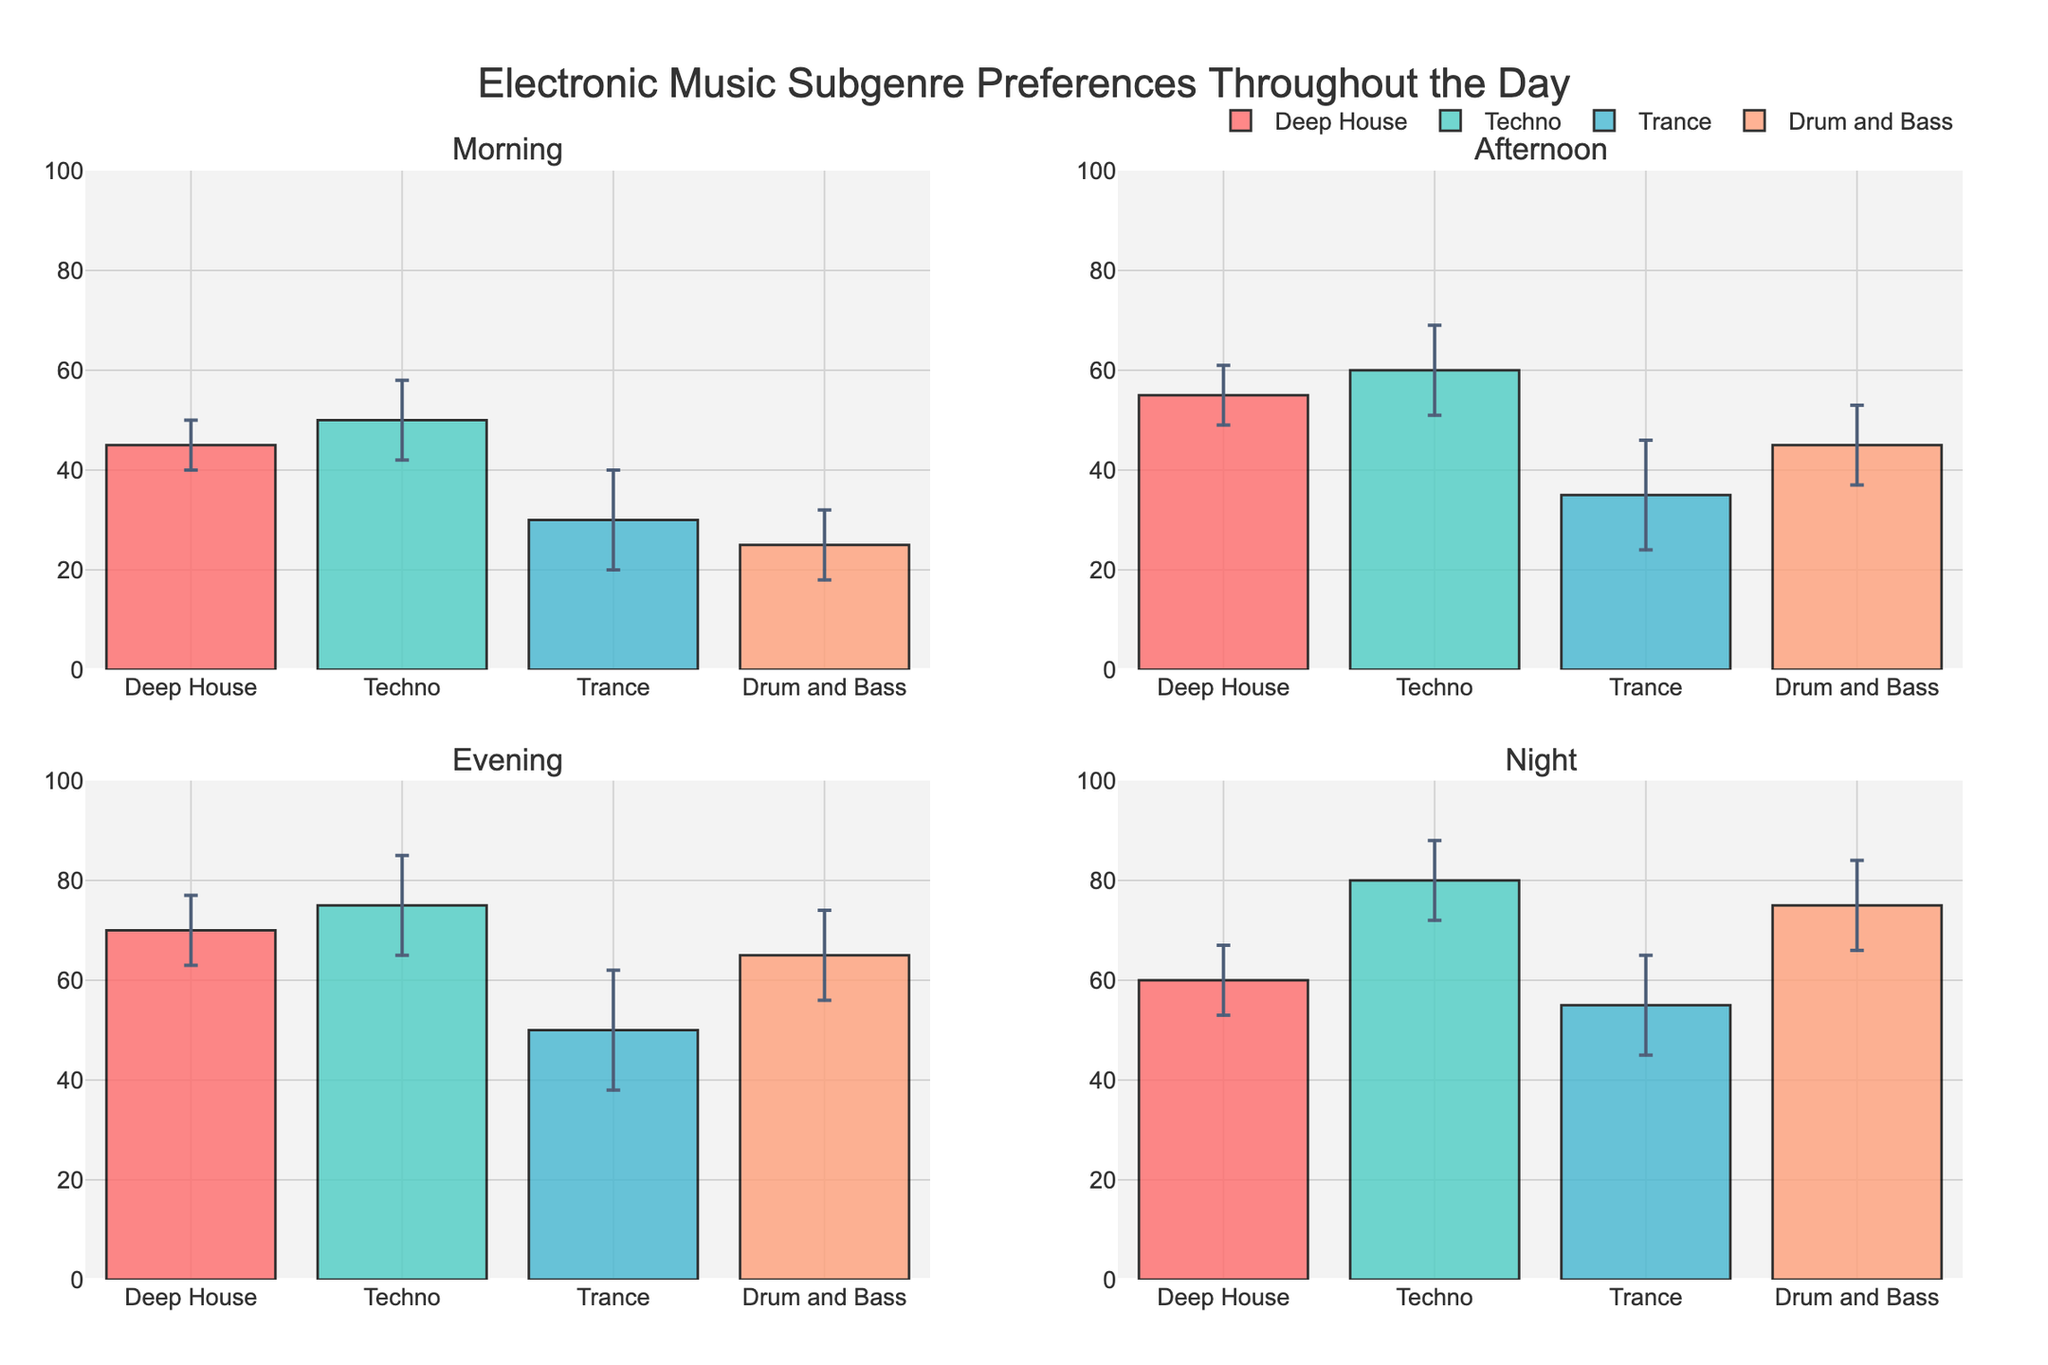What is the title of the figure? The title is placed at the top of the figure, indicating the subject matter of the visual representation.
Answer: Electronic Music Subgenre Preferences Throughout the Day Which electronic music subgenre has the highest mean preference in the Afternoon? Look at the subplot for the Afternoon and compare the height of the bars. The tallest bar corresponds to the highest mean preference.
Answer: Techno How does the mean preference for Drum and Bass change from Morning to Night? Examine the height of the Drum and Bass bars in the Morning and Night subplots and subtract the Morning value from the Night value.
Answer: It increases by 50 What is the standard deviation for Trance in the Evening? Identify the bar for Trance in the Evening subplot and look for the error bar's size, which corresponds to the standard deviation.
Answer: 12 Which time of day shows the lowest mean preference for Trance? Compare the height of the Trance bars in each subplot (Morning, Afternoon, Evening, Night) and identify the smallest one.
Answer: Morning What is the range of mean preferences for Deep House throughout the day? Identify the bars for Deep House in all subplots and find the minimum and maximum values, then subtract the minimum from the maximum.
Answer: 70 - 45 = 25 If you combine the preference for Techno in Morning and Night, what is the total? Add the mean preference values of Techno in the Morning and Night as shown by the bar heights.
Answer: 50 + 80 = 130 Which subgenre shows the largest increase in mean preference from Morning to Afternoon? Compare the differences between the heights of the bars for each subgenre in the Morning and Afternoon subplots. Identify the subgenre with the largest increase.
Answer: Drum and Bass (45 - 25 = 20) What is the overall trend for Deep House preferences throughout the day? Observe and describe the pattern shown by the heights of the Deep House bars across all subplots (Morning, Afternoon, Evening, Night).
Answer: Increasing, peaks in the Evening, and then slightly decreases at Night Which subgenre has the smallest standard deviation in the Evening? Compare the sizes of the error bars for each subgenre in the Evening subplot and identify the smallest one.
Answer: Deep House 